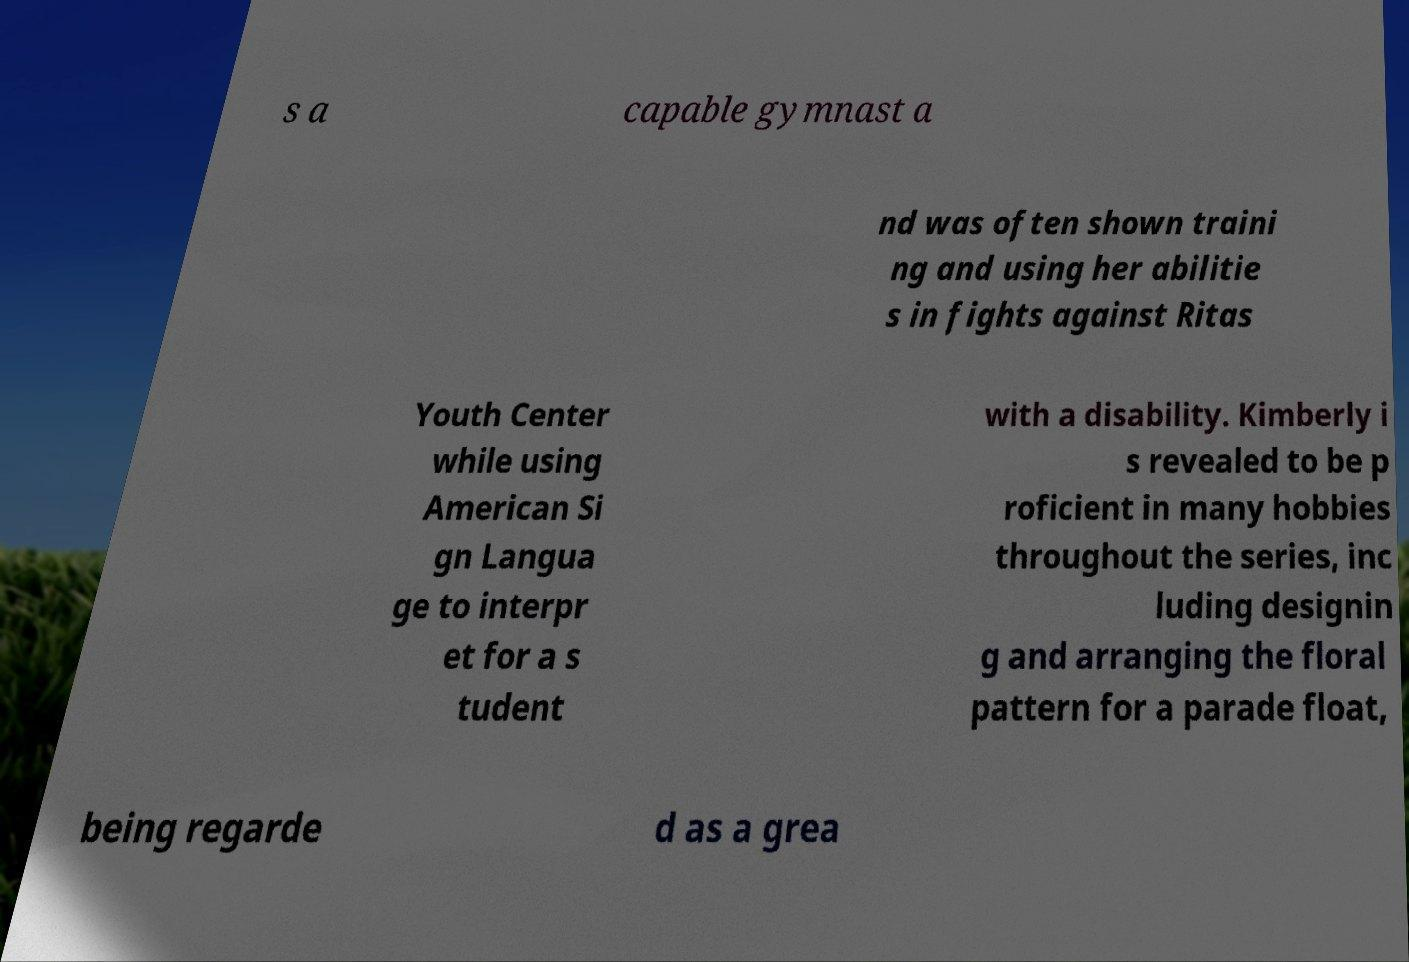Please identify and transcribe the text found in this image. s a capable gymnast a nd was often shown traini ng and using her abilitie s in fights against Ritas Youth Center while using American Si gn Langua ge to interpr et for a s tudent with a disability. Kimberly i s revealed to be p roficient in many hobbies throughout the series, inc luding designin g and arranging the floral pattern for a parade float, being regarde d as a grea 